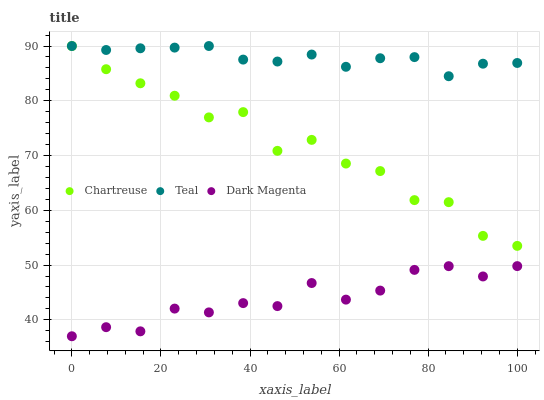Does Dark Magenta have the minimum area under the curve?
Answer yes or no. Yes. Does Teal have the maximum area under the curve?
Answer yes or no. Yes. Does Teal have the minimum area under the curve?
Answer yes or no. No. Does Dark Magenta have the maximum area under the curve?
Answer yes or no. No. Is Teal the smoothest?
Answer yes or no. Yes. Is Chartreuse the roughest?
Answer yes or no. Yes. Is Dark Magenta the smoothest?
Answer yes or no. No. Is Dark Magenta the roughest?
Answer yes or no. No. Does Dark Magenta have the lowest value?
Answer yes or no. Yes. Does Teal have the lowest value?
Answer yes or no. No. Does Teal have the highest value?
Answer yes or no. Yes. Does Dark Magenta have the highest value?
Answer yes or no. No. Is Dark Magenta less than Teal?
Answer yes or no. Yes. Is Teal greater than Dark Magenta?
Answer yes or no. Yes. Does Chartreuse intersect Teal?
Answer yes or no. Yes. Is Chartreuse less than Teal?
Answer yes or no. No. Is Chartreuse greater than Teal?
Answer yes or no. No. Does Dark Magenta intersect Teal?
Answer yes or no. No. 